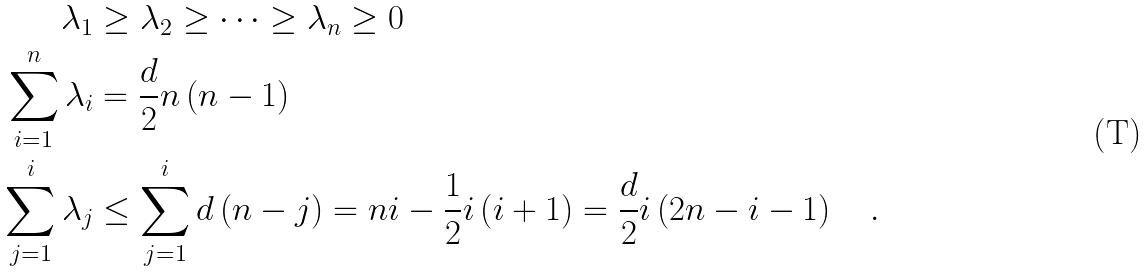<formula> <loc_0><loc_0><loc_500><loc_500>\lambda _ { 1 } & \geq \lambda _ { 2 } \geq \cdots \geq \lambda _ { n } \geq 0 \\ \sum _ { i = 1 } ^ { n } \lambda _ { i } & = \frac { d } { 2 } n \left ( n - 1 \right ) \\ \sum _ { j = 1 } ^ { i } \lambda _ { j } & \leq \sum _ { j = 1 } ^ { i } d \left ( n - j \right ) = n i - \frac { 1 } { 2 } i \left ( i + 1 \right ) = \frac { d } { 2 } i \left ( 2 n - i - 1 \right ) \quad .</formula> 